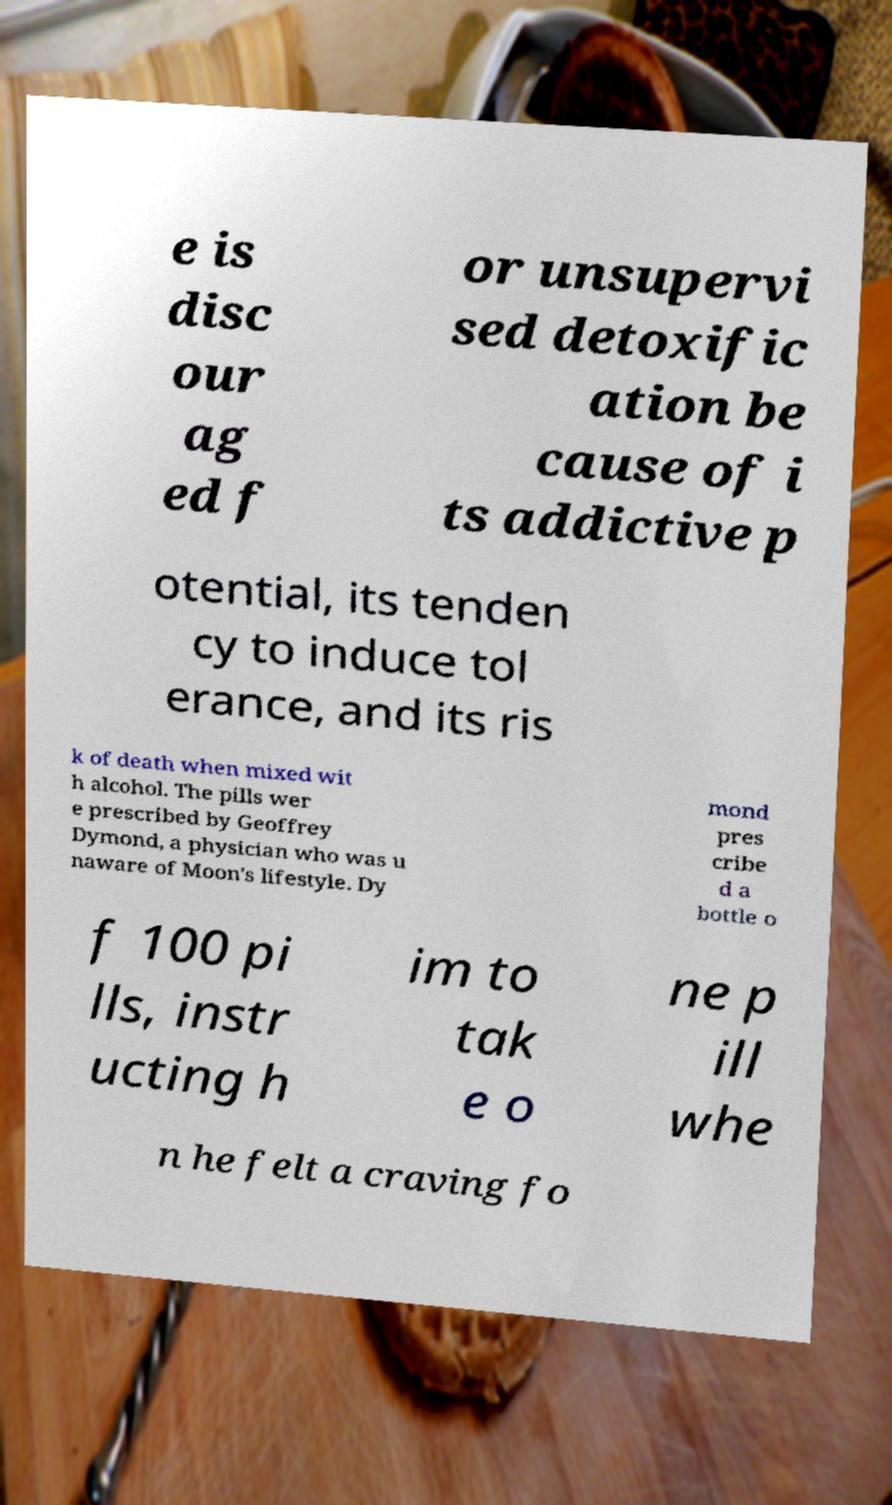Please read and relay the text visible in this image. What does it say? e is disc our ag ed f or unsupervi sed detoxific ation be cause of i ts addictive p otential, its tenden cy to induce tol erance, and its ris k of death when mixed wit h alcohol. The pills wer e prescribed by Geoffrey Dymond, a physician who was u naware of Moon's lifestyle. Dy mond pres cribe d a bottle o f 100 pi lls, instr ucting h im to tak e o ne p ill whe n he felt a craving fo 